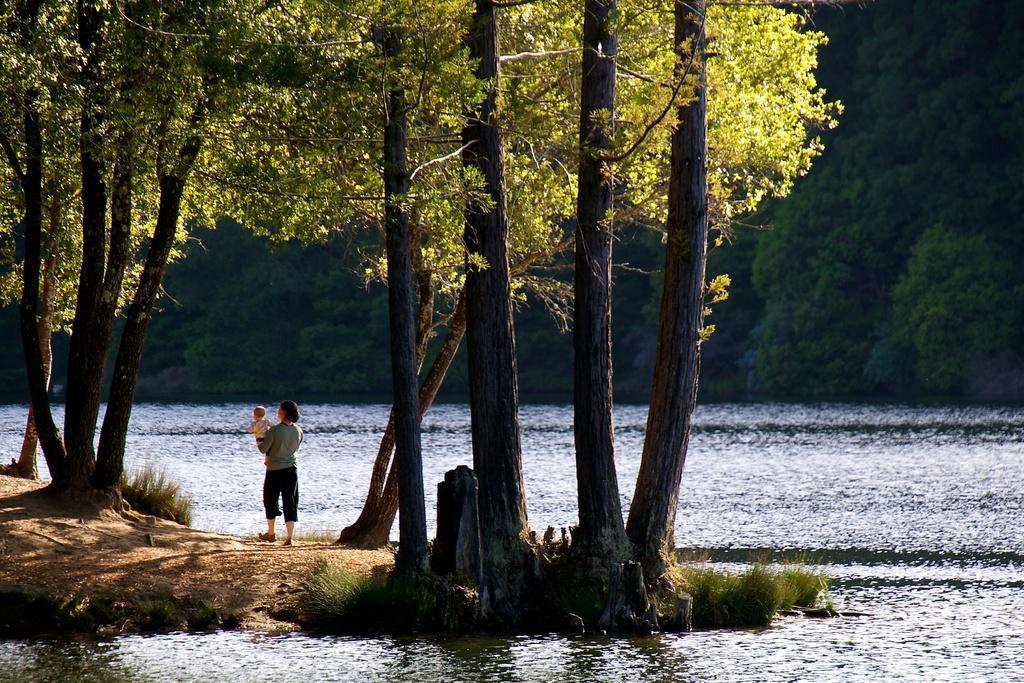How would you summarize this image in a sentence or two? In this image, I can see a person carrying a baby. It looks like a river. I can see the trees with branches and leaves. I think this is the grass. 